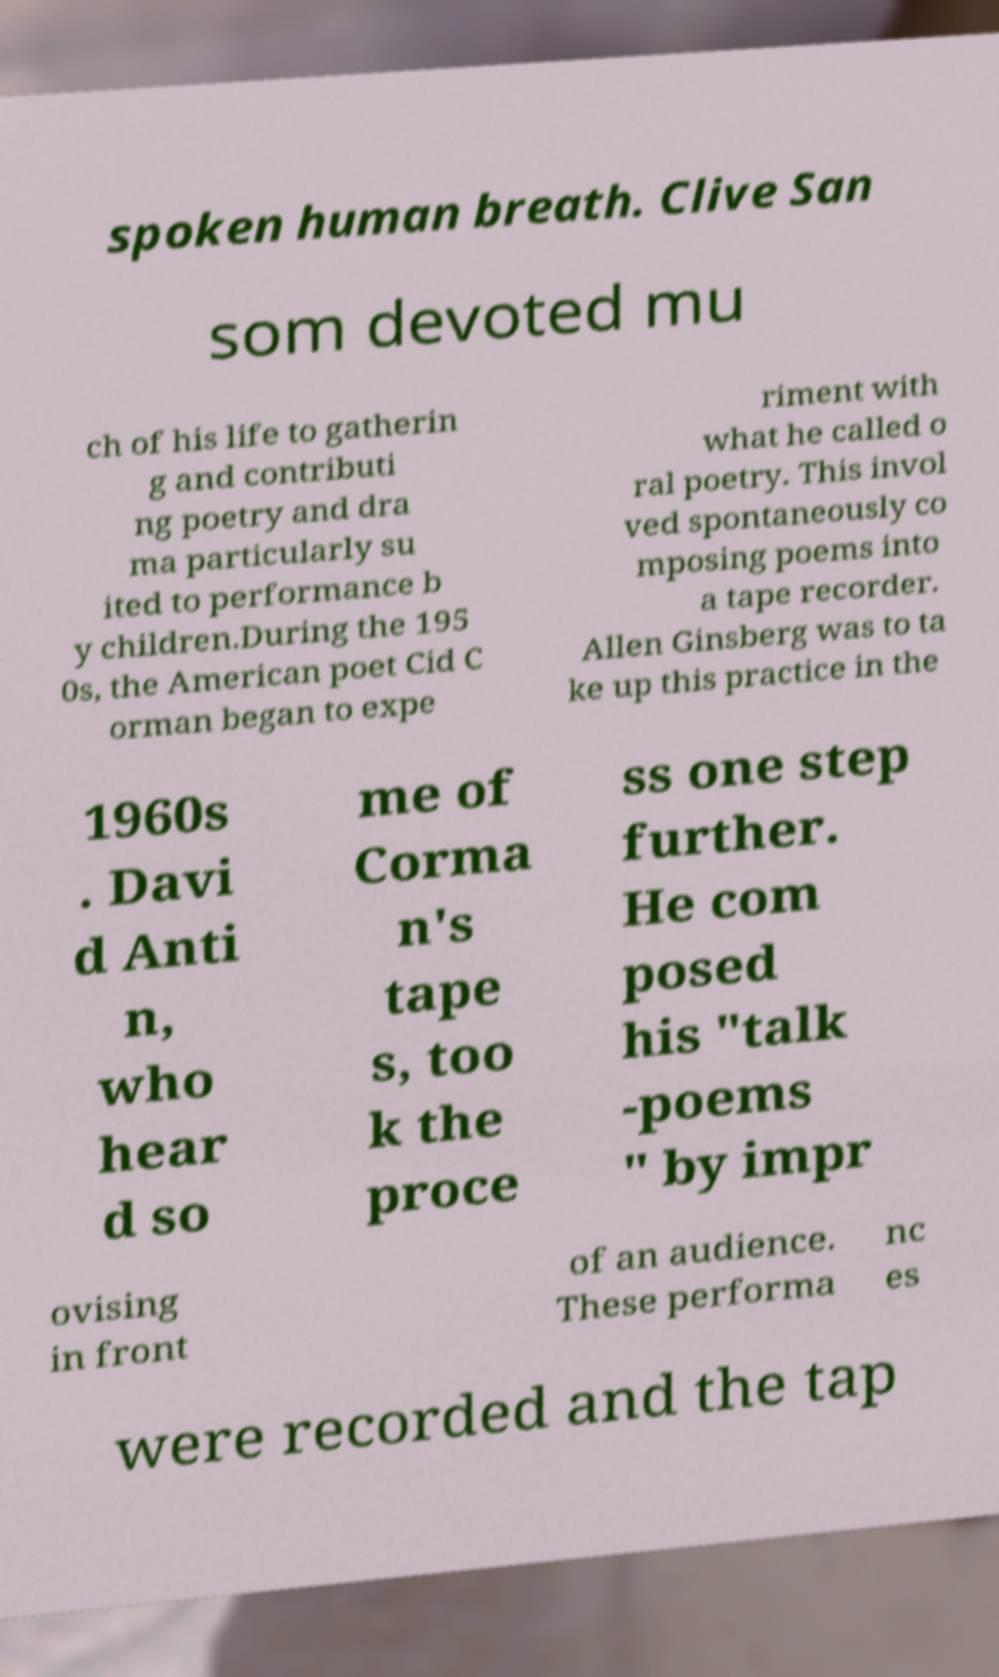Please read and relay the text visible in this image. What does it say? spoken human breath. Clive San som devoted mu ch of his life to gatherin g and contributi ng poetry and dra ma particularly su ited to performance b y children.During the 195 0s, the American poet Cid C orman began to expe riment with what he called o ral poetry. This invol ved spontaneously co mposing poems into a tape recorder. Allen Ginsberg was to ta ke up this practice in the 1960s . Davi d Anti n, who hear d so me of Corma n's tape s, too k the proce ss one step further. He com posed his "talk -poems " by impr ovising in front of an audience. These performa nc es were recorded and the tap 